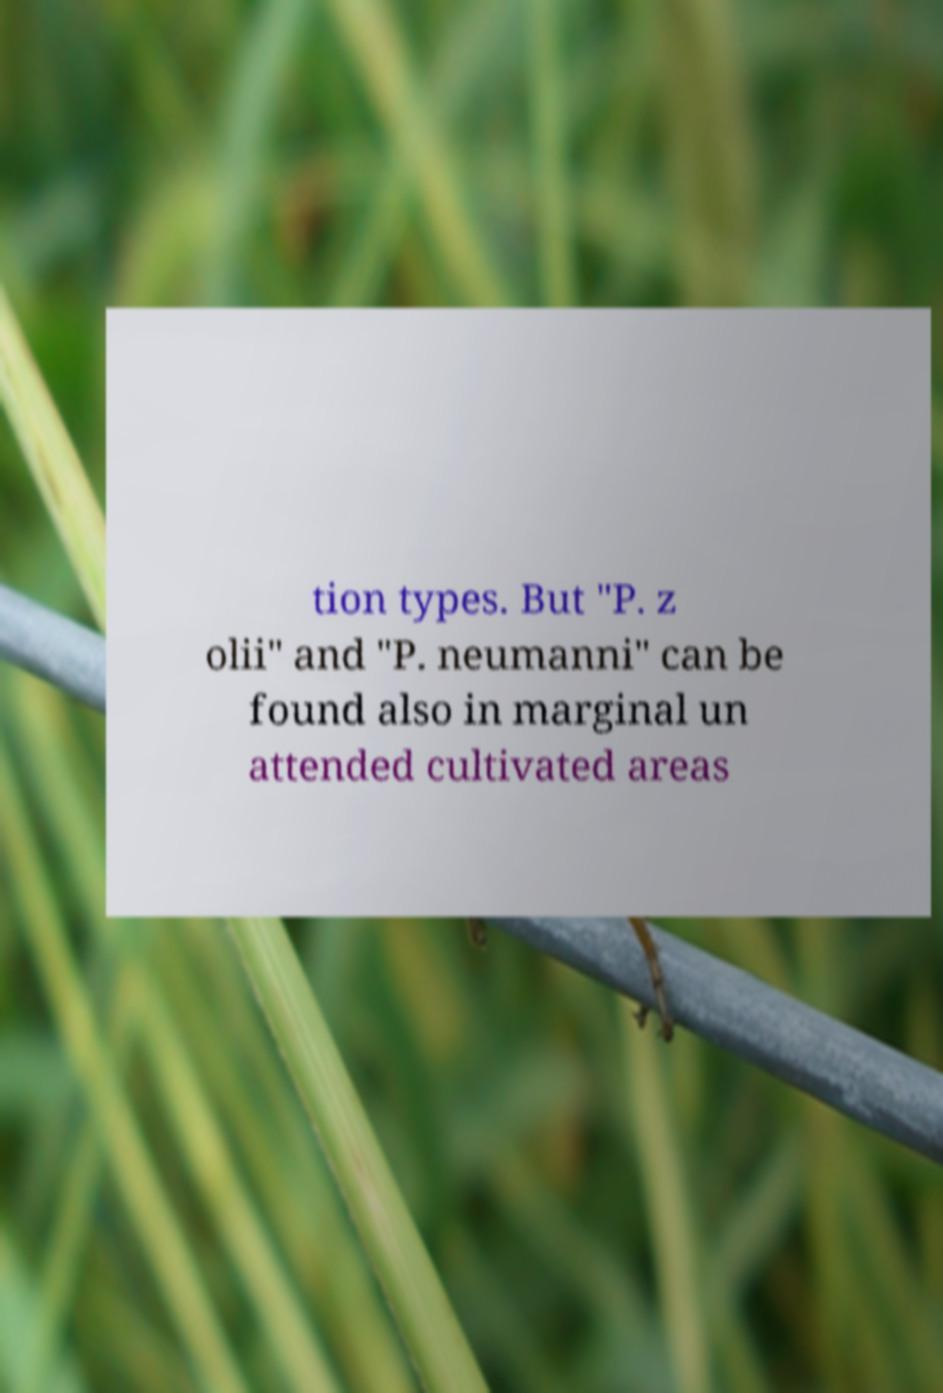What messages or text are displayed in this image? I need them in a readable, typed format. tion types. But "P. z olii" and "P. neumanni" can be found also in marginal un attended cultivated areas 